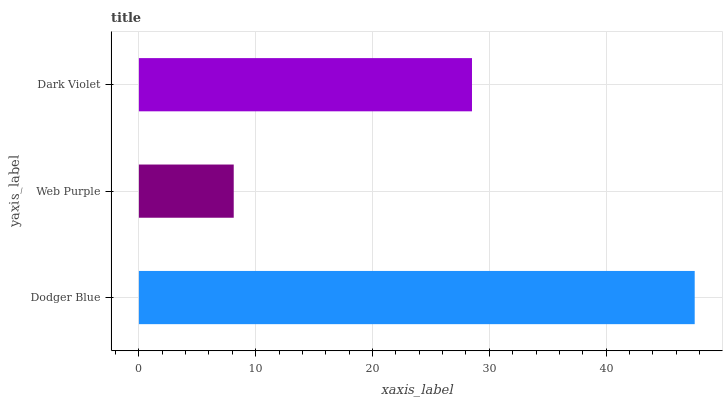Is Web Purple the minimum?
Answer yes or no. Yes. Is Dodger Blue the maximum?
Answer yes or no. Yes. Is Dark Violet the minimum?
Answer yes or no. No. Is Dark Violet the maximum?
Answer yes or no. No. Is Dark Violet greater than Web Purple?
Answer yes or no. Yes. Is Web Purple less than Dark Violet?
Answer yes or no. Yes. Is Web Purple greater than Dark Violet?
Answer yes or no. No. Is Dark Violet less than Web Purple?
Answer yes or no. No. Is Dark Violet the high median?
Answer yes or no. Yes. Is Dark Violet the low median?
Answer yes or no. Yes. Is Dodger Blue the high median?
Answer yes or no. No. Is Dodger Blue the low median?
Answer yes or no. No. 